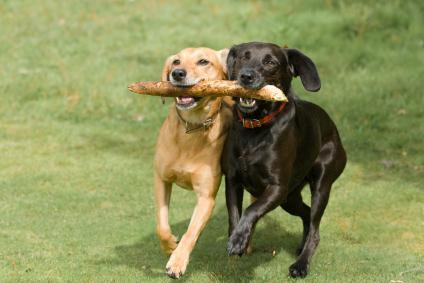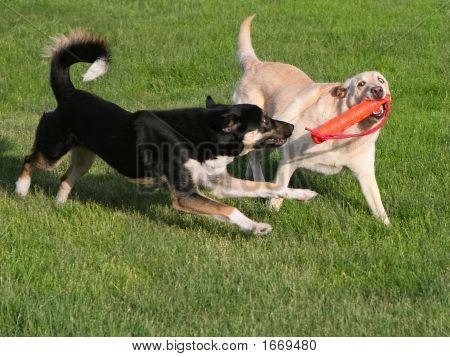The first image is the image on the left, the second image is the image on the right. Assess this claim about the two images: "There are four dogs in total.". Correct or not? Answer yes or no. Yes. The first image is the image on the left, the second image is the image on the right. For the images shown, is this caption "There are three black dogs in the grass." true? Answer yes or no. No. 